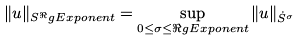<formula> <loc_0><loc_0><loc_500><loc_500>\| u \| _ { S ^ { \Re } g E x p o n e n t } = \sup _ { 0 \leq \sigma \leq \Re g E x p o n e n t } \| u \| _ { \dot { S } ^ { \sigma } }</formula> 